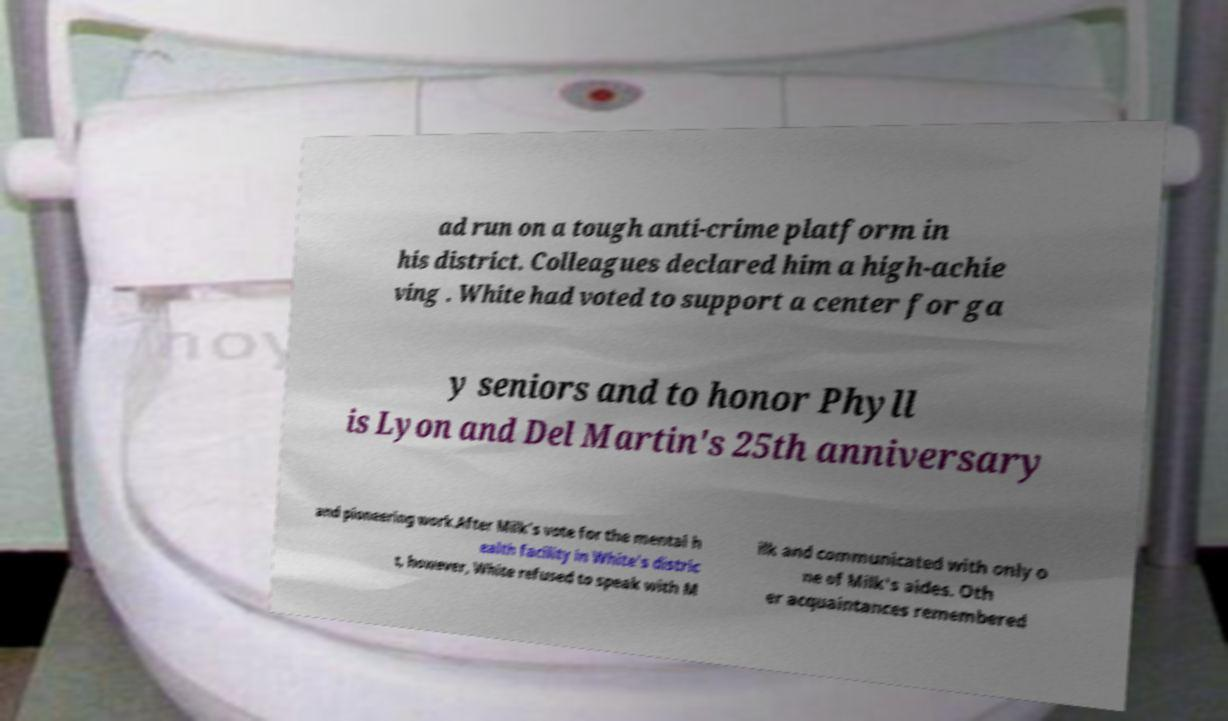There's text embedded in this image that I need extracted. Can you transcribe it verbatim? ad run on a tough anti-crime platform in his district. Colleagues declared him a high-achie ving . White had voted to support a center for ga y seniors and to honor Phyll is Lyon and Del Martin's 25th anniversary and pioneering work.After Milk's vote for the mental h ealth facility in White's distric t, however, White refused to speak with M ilk and communicated with only o ne of Milk's aides. Oth er acquaintances remembered 